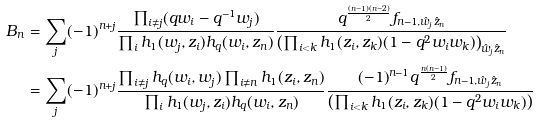<formula> <loc_0><loc_0><loc_500><loc_500>B _ { n } & = \sum _ { j } ( - 1 ) ^ { n + j } \frac { \prod _ { i \neq j } ( q w _ { i } - q ^ { - 1 } w _ { j } ) } { \prod _ { i } h _ { 1 } ( w _ { j } , z _ { i } ) h _ { q } ( w _ { i } , z _ { n } ) } \frac { q ^ { \frac { ( n - 1 ) ( n - 2 ) } { 2 } } f _ { n - 1 , \hat { w } _ { j } \hat { z } _ { n } } } { \left ( \prod _ { i < k } h _ { 1 } ( z _ { i } , z _ { k } ) ( 1 - q ^ { 2 } w _ { i } w _ { k } ) \right ) _ { \hat { w } _ { j } \hat { z } _ { n } } } \\ & = \sum _ { j } ( - 1 ) ^ { n + j } \frac { \prod _ { i \neq j } h _ { q } ( w _ { i } , w _ { j } ) \prod _ { i \neq n } h _ { 1 } ( z _ { i } , z _ { n } ) } { \prod _ { i } h _ { 1 } ( w _ { j } , z _ { i } ) h _ { q } ( w _ { i } , z _ { n } ) } \frac { ( - 1 ) ^ { n - 1 } q ^ { \frac { n ( n - 1 ) } { 2 } } f _ { n - 1 , \hat { w } _ { j } \hat { z } _ { n } } } { \left ( \prod _ { i < k } h _ { 1 } ( z _ { i } , z _ { k } ) ( 1 - q ^ { 2 } w _ { i } w _ { k } ) \right ) }</formula> 